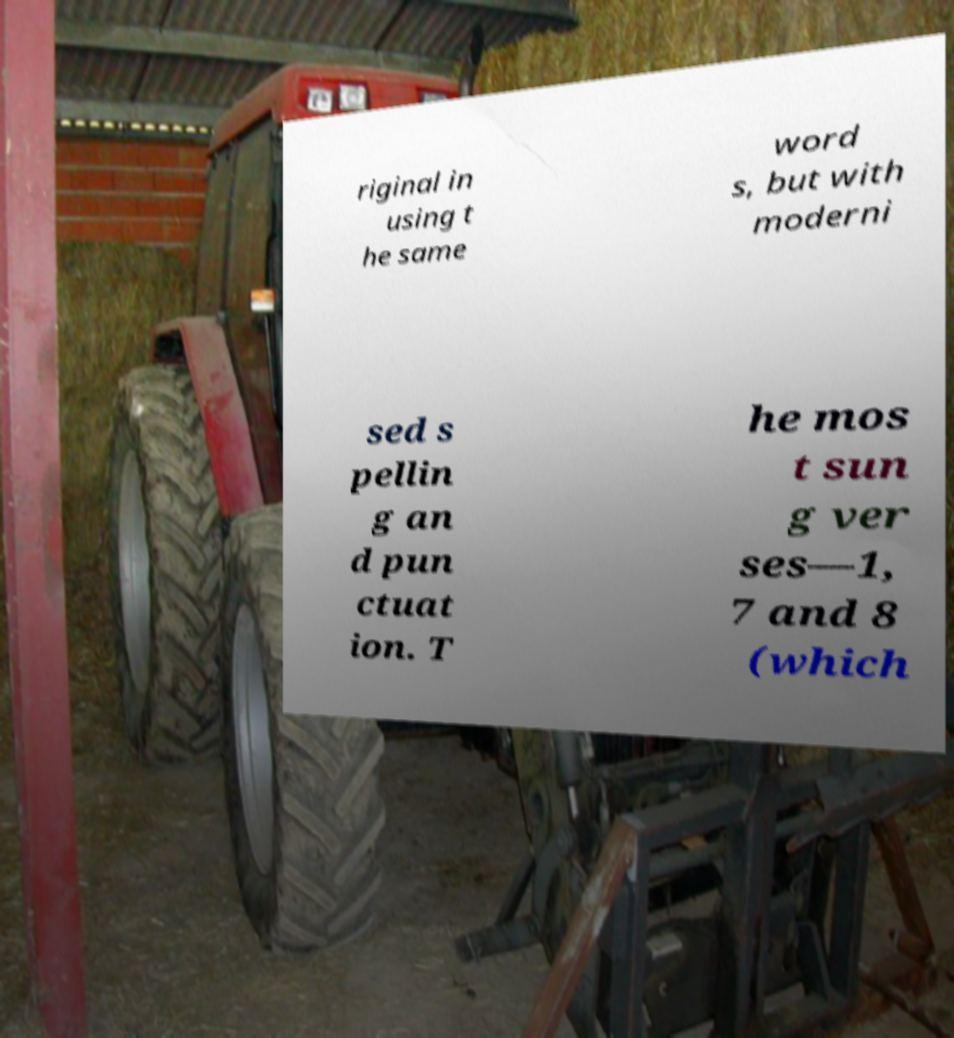Could you extract and type out the text from this image? riginal in using t he same word s, but with moderni sed s pellin g an d pun ctuat ion. T he mos t sun g ver ses—1, 7 and 8 (which 